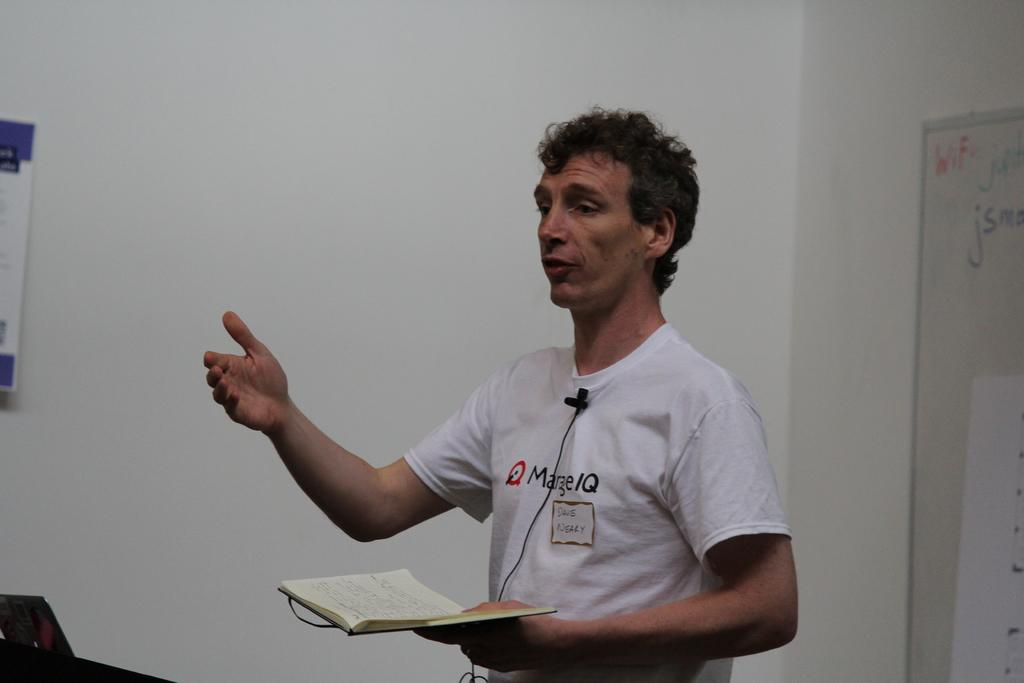<image>
Give a short and clear explanation of the subsequent image. Mr Nealy reading a story from an open book he holds 